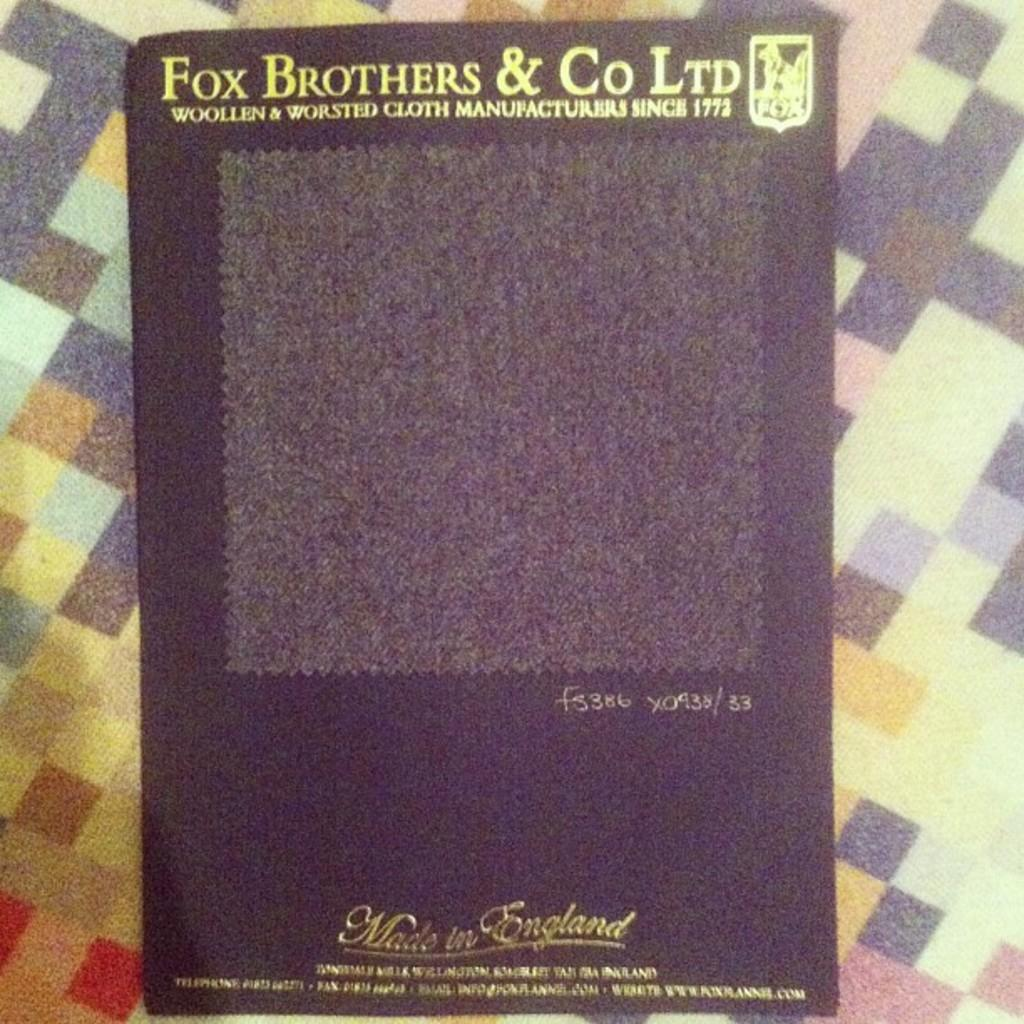What is the main subject of the image? The main subject of the image is a book cover. What can be seen on the book cover? There is text and a logo on the book cover. How would you describe the background of the image? The background of the image is colorful. What type of flower is depicted on the book cover? There is no flower depicted on the book cover; the image features a book cover with text and a logo. 